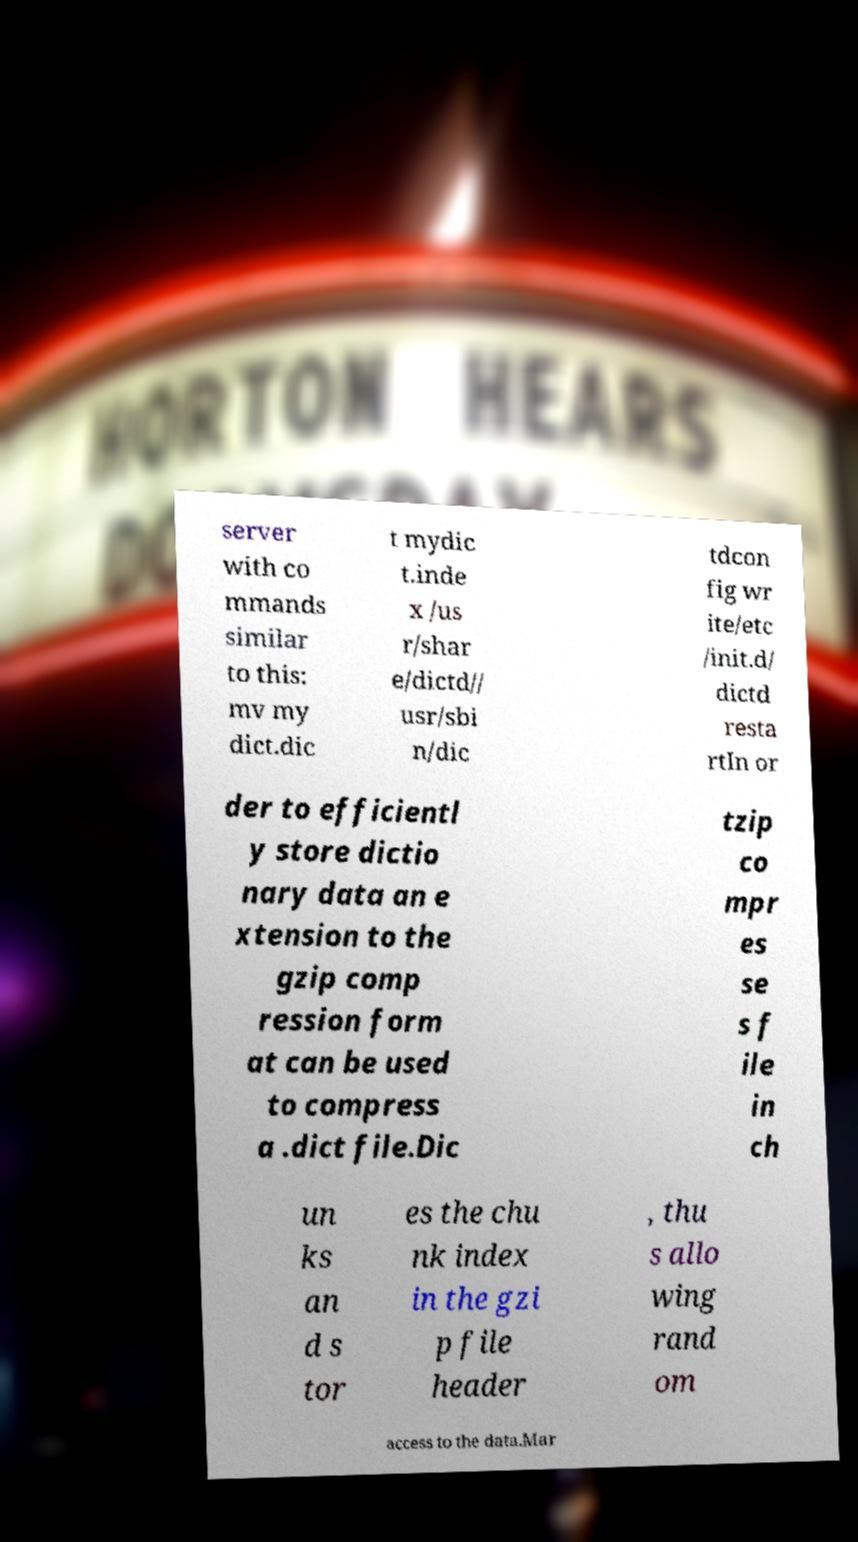Could you extract and type out the text from this image? server with co mmands similar to this: mv my dict.dic t mydic t.inde x /us r/shar e/dictd// usr/sbi n/dic tdcon fig wr ite/etc /init.d/ dictd resta rtIn or der to efficientl y store dictio nary data an e xtension to the gzip comp ression form at can be used to compress a .dict file.Dic tzip co mpr es se s f ile in ch un ks an d s tor es the chu nk index in the gzi p file header , thu s allo wing rand om access to the data.Mar 